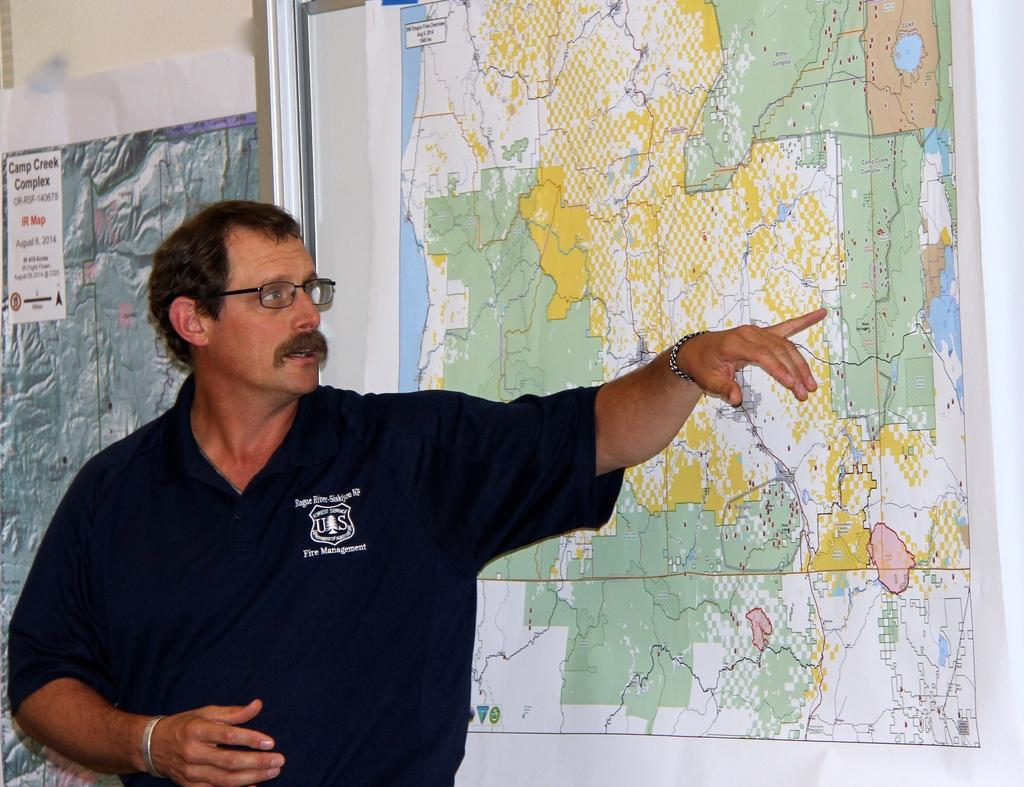Who is present in the image? There is a man in the image. Where is the man positioned in the image? The man is standing on the left side of the image. What is the man interacting with in the image? There is a map in front of the man. Can you describe the background of the image? There is another map behind the man. What type of bird can be seen using a wrench on the map in the image? There are no birds present in the image, and no wrenches are visible. 